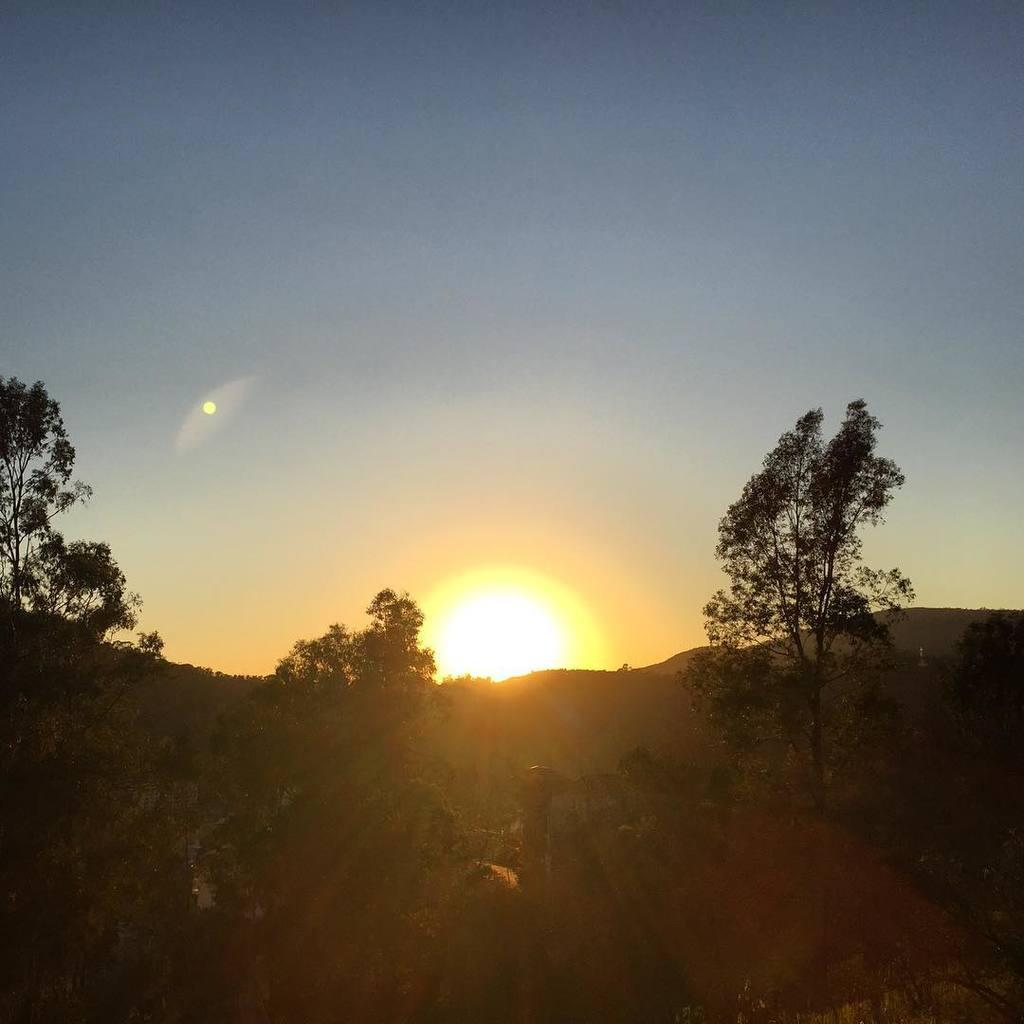What type of natural elements can be seen in the image? There are trees and mountains in the image. What is the time of day depicted in the image? There is a sunset visible in the sky, indicating that it is late afternoon or early evening. What type of brush is being used to paint the dirt in the image? There is no brush or painting activity present in the image; it features trees, mountains, and a sunset. 